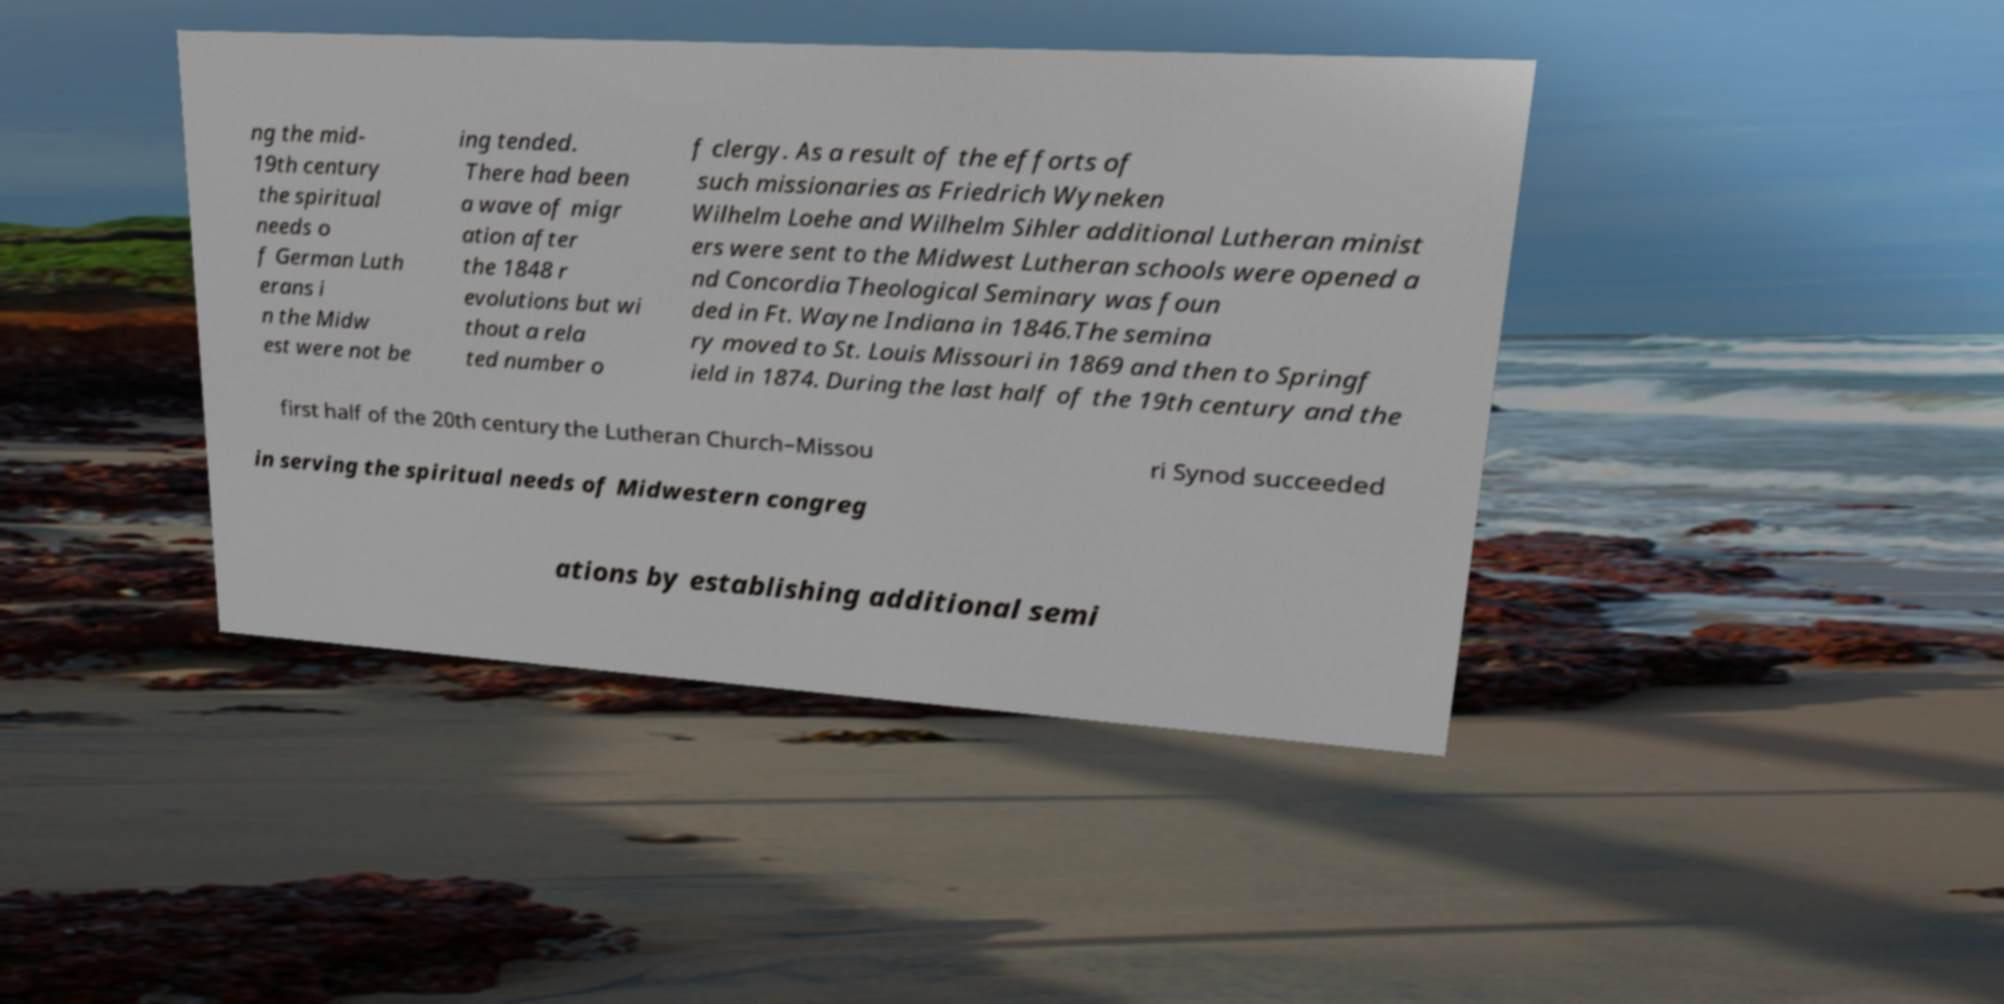Could you extract and type out the text from this image? ng the mid- 19th century the spiritual needs o f German Luth erans i n the Midw est were not be ing tended. There had been a wave of migr ation after the 1848 r evolutions but wi thout a rela ted number o f clergy. As a result of the efforts of such missionaries as Friedrich Wyneken Wilhelm Loehe and Wilhelm Sihler additional Lutheran minist ers were sent to the Midwest Lutheran schools were opened a nd Concordia Theological Seminary was foun ded in Ft. Wayne Indiana in 1846.The semina ry moved to St. Louis Missouri in 1869 and then to Springf ield in 1874. During the last half of the 19th century and the first half of the 20th century the Lutheran Church–Missou ri Synod succeeded in serving the spiritual needs of Midwestern congreg ations by establishing additional semi 